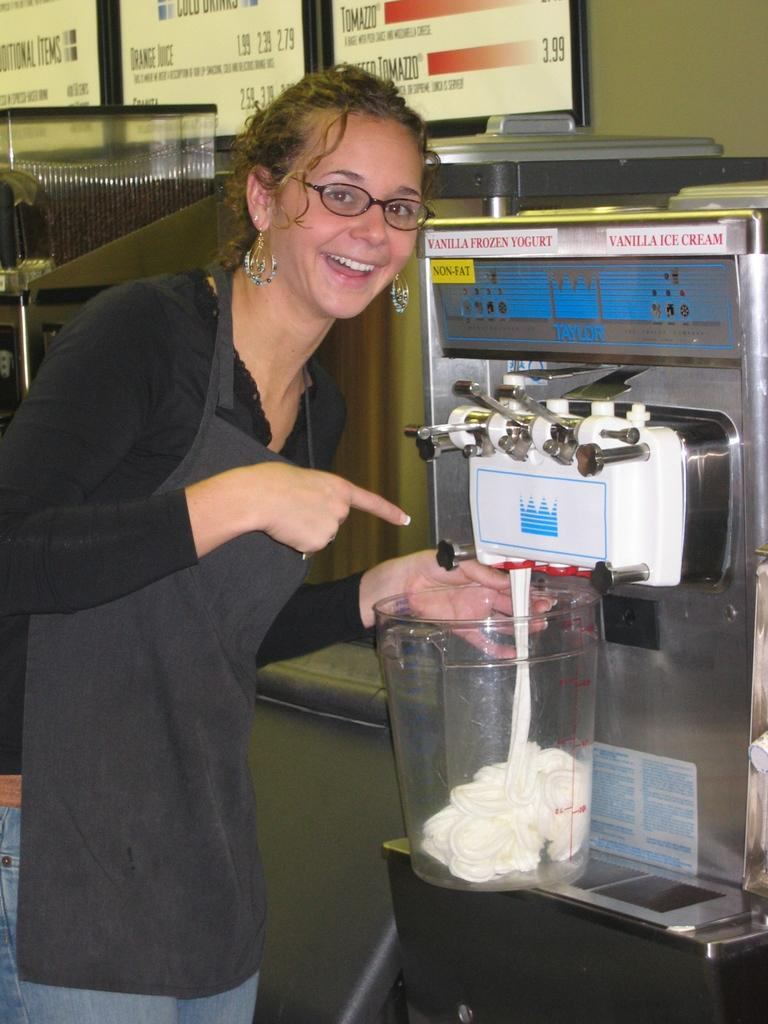<image>
Give a short and clear explanation of the subsequent image. A woman pointing at an ice cream machine that has a sign vanilla frozen yogurt 